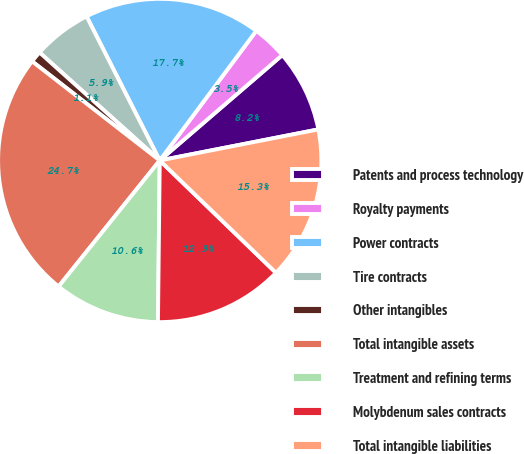Convert chart to OTSL. <chart><loc_0><loc_0><loc_500><loc_500><pie_chart><fcel>Patents and process technology<fcel>Royalty payments<fcel>Power contracts<fcel>Tire contracts<fcel>Other intangibles<fcel>Total intangible assets<fcel>Treatment and refining terms<fcel>Molybdenum sales contracts<fcel>Total intangible liabilities<nl><fcel>8.23%<fcel>3.51%<fcel>17.67%<fcel>5.87%<fcel>1.14%<fcel>24.75%<fcel>10.59%<fcel>12.95%<fcel>15.31%<nl></chart> 